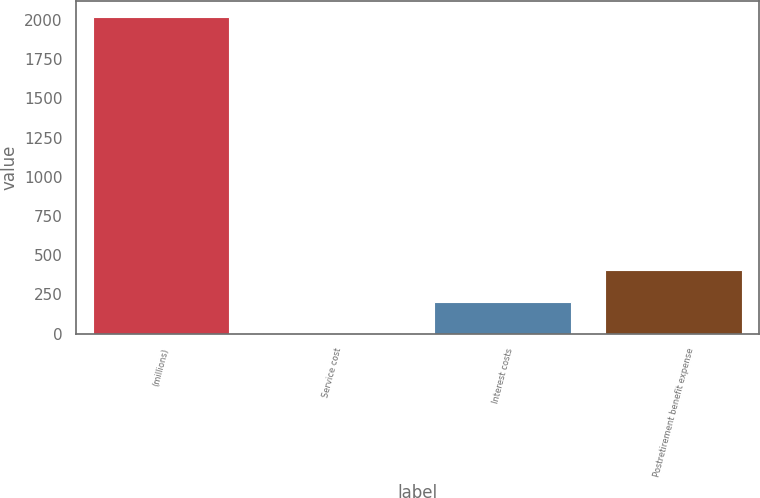Convert chart to OTSL. <chart><loc_0><loc_0><loc_500><loc_500><bar_chart><fcel>(millions)<fcel>Service cost<fcel>Interest costs<fcel>Postretirement benefit expense<nl><fcel>2018<fcel>2<fcel>203.6<fcel>405.2<nl></chart> 